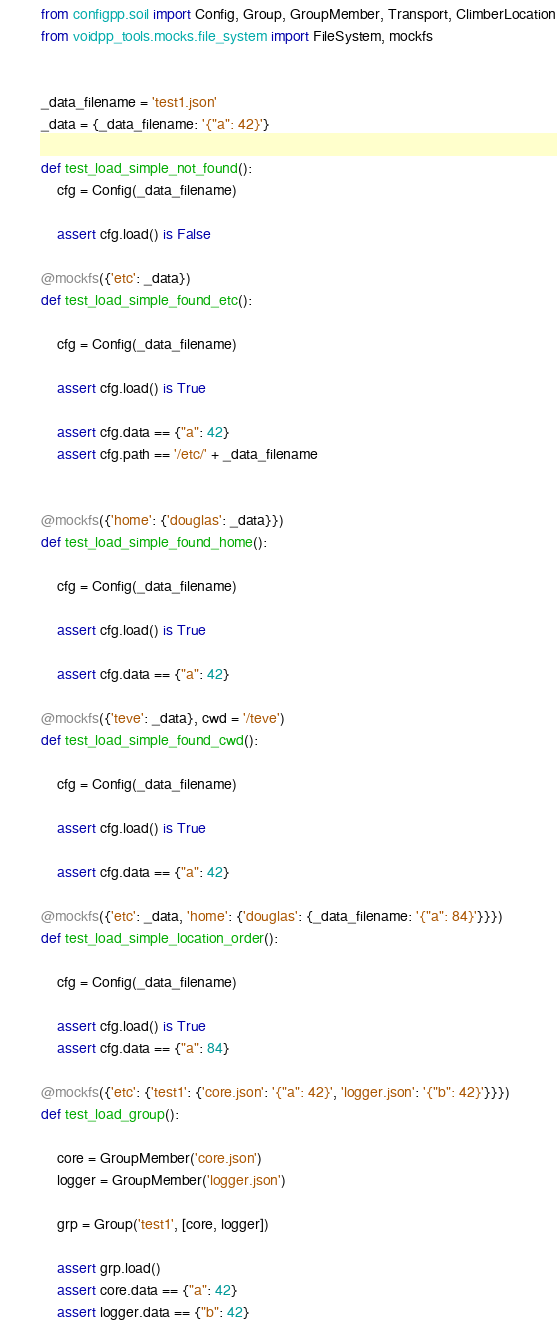Convert code to text. <code><loc_0><loc_0><loc_500><loc_500><_Python_>
from configpp.soil import Config, Group, GroupMember, Transport, ClimberLocation
from voidpp_tools.mocks.file_system import FileSystem, mockfs


_data_filename = 'test1.json'
_data = {_data_filename: '{"a": 42}'}

def test_load_simple_not_found():
    cfg = Config(_data_filename)

    assert cfg.load() is False

@mockfs({'etc': _data})
def test_load_simple_found_etc():

    cfg = Config(_data_filename)

    assert cfg.load() is True

    assert cfg.data == {"a": 42}
    assert cfg.path == '/etc/' + _data_filename


@mockfs({'home': {'douglas': _data}})
def test_load_simple_found_home():

    cfg = Config(_data_filename)

    assert cfg.load() is True

    assert cfg.data == {"a": 42}

@mockfs({'teve': _data}, cwd = '/teve')
def test_load_simple_found_cwd():

    cfg = Config(_data_filename)

    assert cfg.load() is True

    assert cfg.data == {"a": 42}

@mockfs({'etc': _data, 'home': {'douglas': {_data_filename: '{"a": 84}'}}})
def test_load_simple_location_order():

    cfg = Config(_data_filename)

    assert cfg.load() is True
    assert cfg.data == {"a": 84}

@mockfs({'etc': {'test1': {'core.json': '{"a": 42}', 'logger.json': '{"b": 42}'}}})
def test_load_group():

    core = GroupMember('core.json')
    logger = GroupMember('logger.json')

    grp = Group('test1', [core, logger])

    assert grp.load()
    assert core.data == {"a": 42}
    assert logger.data == {"b": 42}
</code> 